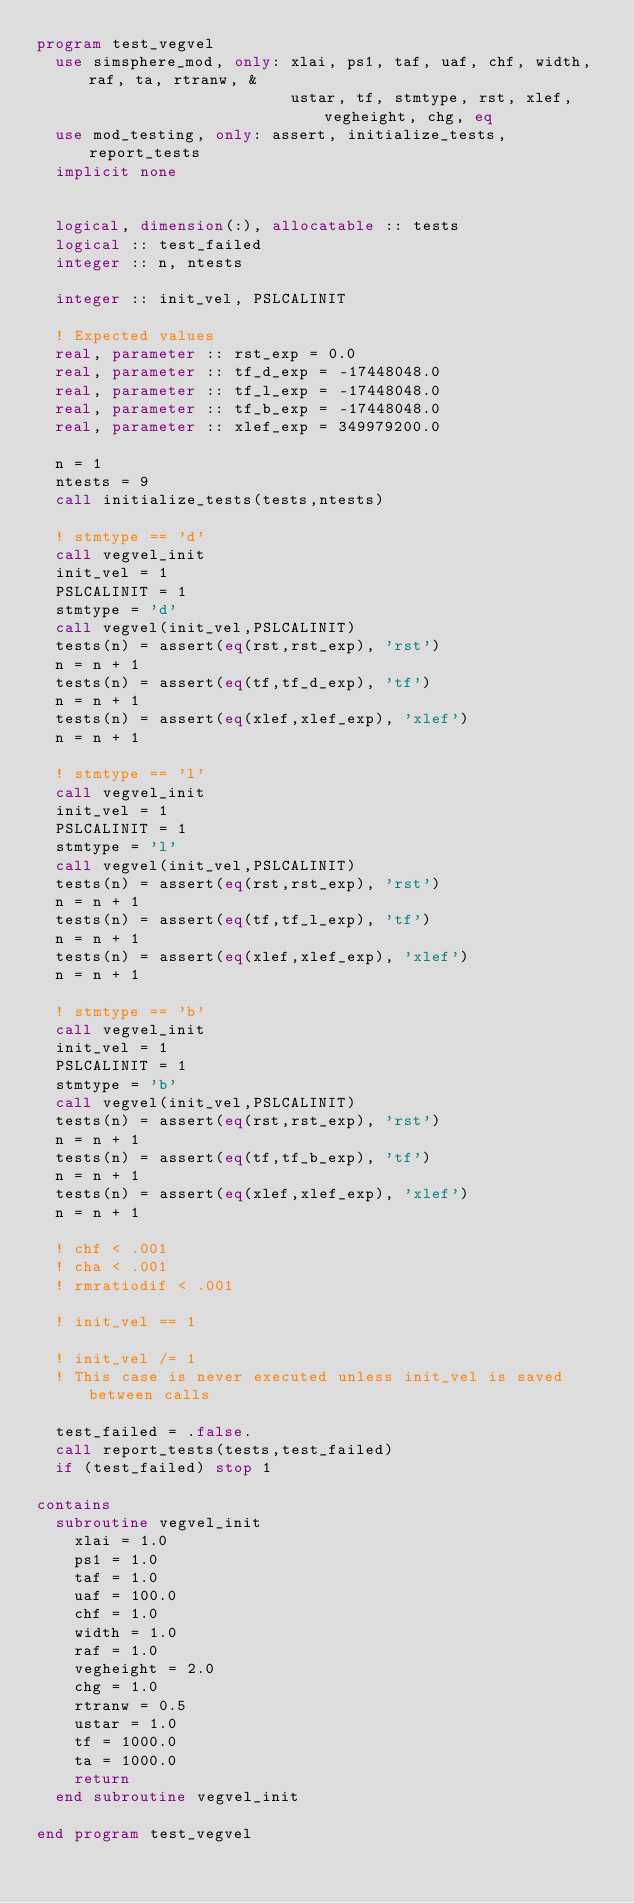Convert code to text. <code><loc_0><loc_0><loc_500><loc_500><_FORTRAN_>program test_vegvel
  use simsphere_mod, only: xlai, ps1, taf, uaf, chf, width, raf, ta, rtranw, &
                           ustar, tf, stmtype, rst, xlef, vegheight, chg, eq
  use mod_testing, only: assert, initialize_tests, report_tests
  implicit none


  logical, dimension(:), allocatable :: tests
  logical :: test_failed
  integer :: n, ntests

  integer :: init_vel, PSLCALINIT

  ! Expected values
  real, parameter :: rst_exp = 0.0
  real, parameter :: tf_d_exp = -17448048.0
  real, parameter :: tf_l_exp = -17448048.0
  real, parameter :: tf_b_exp = -17448048.0
  real, parameter :: xlef_exp = 349979200.0

  n = 1
  ntests = 9
  call initialize_tests(tests,ntests)

  ! stmtype == 'd'
  call vegvel_init
  init_vel = 1
  PSLCALINIT = 1
  stmtype = 'd'
  call vegvel(init_vel,PSLCALINIT)
  tests(n) = assert(eq(rst,rst_exp), 'rst')
  n = n + 1
  tests(n) = assert(eq(tf,tf_d_exp), 'tf')
  n = n + 1
  tests(n) = assert(eq(xlef,xlef_exp), 'xlef')
  n = n + 1

  ! stmtype == 'l'
  call vegvel_init
  init_vel = 1
  PSLCALINIT = 1
  stmtype = 'l'
  call vegvel(init_vel,PSLCALINIT)
  tests(n) = assert(eq(rst,rst_exp), 'rst')
  n = n + 1
  tests(n) = assert(eq(tf,tf_l_exp), 'tf')
  n = n + 1
  tests(n) = assert(eq(xlef,xlef_exp), 'xlef')
  n = n + 1

  ! stmtype == 'b'
  call vegvel_init
  init_vel = 1
  PSLCALINIT = 1
  stmtype = 'b'
  call vegvel(init_vel,PSLCALINIT)
  tests(n) = assert(eq(rst,rst_exp), 'rst')
  n = n + 1
  tests(n) = assert(eq(tf,tf_b_exp), 'tf')
  n = n + 1
  tests(n) = assert(eq(xlef,xlef_exp), 'xlef')
  n = n + 1

  ! chf < .001
  ! cha < .001
  ! rmratiodif < .001

  ! init_vel == 1

  ! init_vel /= 1
  ! This case is never executed unless init_vel is saved between calls

  test_failed = .false.
  call report_tests(tests,test_failed)
  if (test_failed) stop 1

contains
  subroutine vegvel_init
    xlai = 1.0
    ps1 = 1.0
    taf = 1.0
    uaf = 100.0
    chf = 1.0
    width = 1.0
    raf = 1.0
    vegheight = 2.0
    chg = 1.0
    rtranw = 0.5
    ustar = 1.0
    tf = 1000.0
    ta = 1000.0
    return
  end subroutine vegvel_init

end program test_vegvel
</code> 